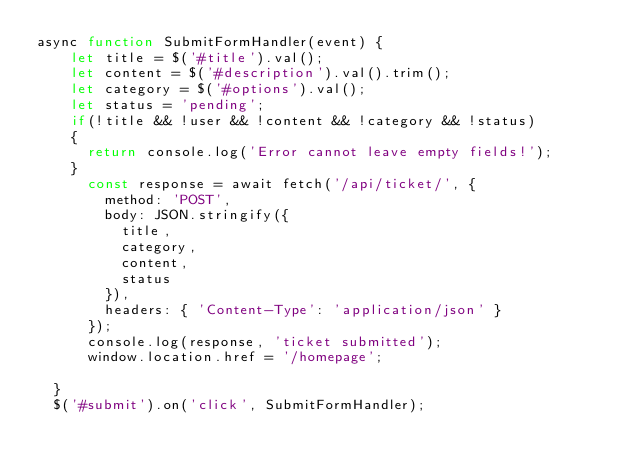<code> <loc_0><loc_0><loc_500><loc_500><_JavaScript_>async function SubmitFormHandler(event) {
    let title = $('#title').val();
    let content = $('#description').val().trim();
    let category = $('#options').val();
    let status = 'pending';
    if(!title && !user && !content && !category && !status)
    {
      return console.log('Error cannot leave empty fields!');
    }
      const response = await fetch('/api/ticket/', {
        method: 'POST',
        body: JSON.stringify({
          title,
          category,
          content,
          status
        }),
        headers: { 'Content-Type': 'application/json' }
      });
      console.log(response, 'ticket submitted');
      window.location.href = '/homepage';
    
  }
  $('#submit').on('click', SubmitFormHandler);</code> 